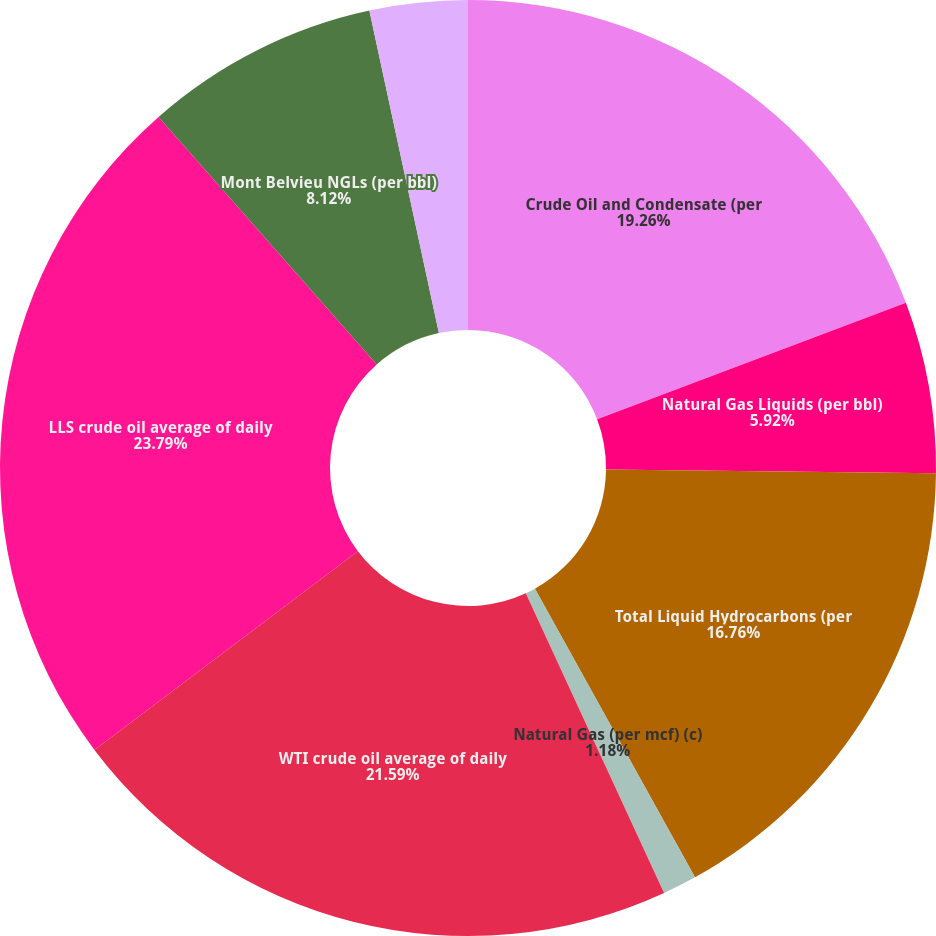Convert chart. <chart><loc_0><loc_0><loc_500><loc_500><pie_chart><fcel>Crude Oil and Condensate (per<fcel>Natural Gas Liquids (per bbl)<fcel>Total Liquid Hydrocarbons (per<fcel>Natural Gas (per mcf) (c)<fcel>WTI crude oil average of daily<fcel>LLS crude oil average of daily<fcel>Mont Belvieu NGLs (per bbl)<fcel>Henry Hub natural gas<nl><fcel>19.26%<fcel>5.92%<fcel>16.76%<fcel>1.18%<fcel>21.59%<fcel>23.79%<fcel>8.12%<fcel>3.38%<nl></chart> 